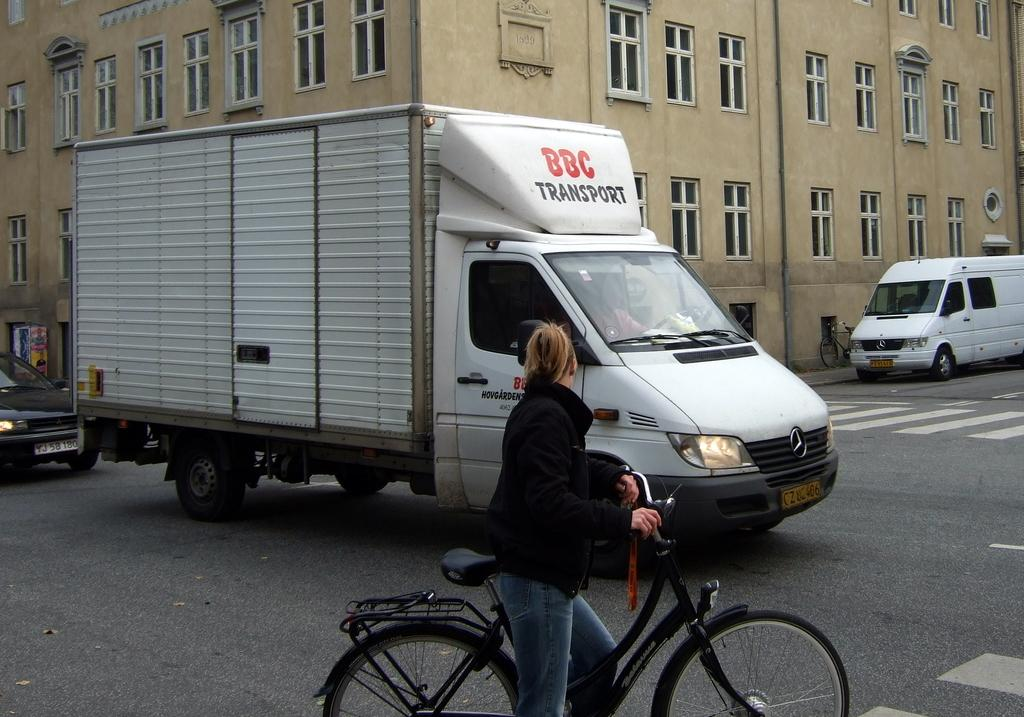<image>
Write a terse but informative summary of the picture. A lady on a bike in front of a white truck from the company BBC Transport. 